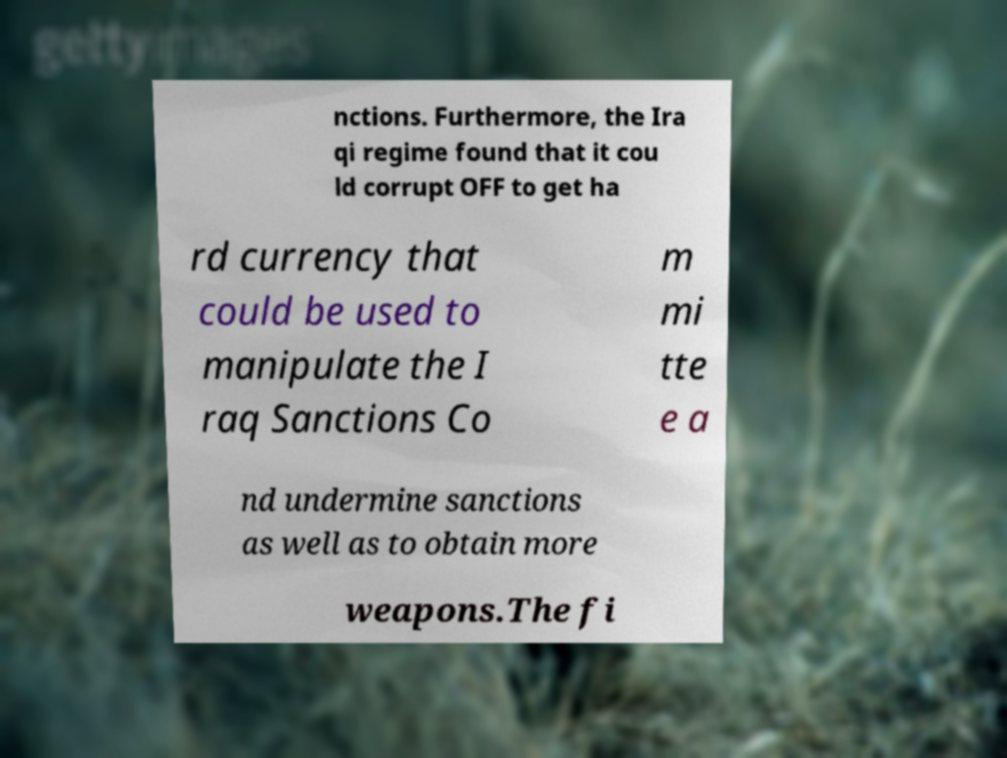What messages or text are displayed in this image? I need them in a readable, typed format. nctions. Furthermore, the Ira qi regime found that it cou ld corrupt OFF to get ha rd currency that could be used to manipulate the I raq Sanctions Co m mi tte e a nd undermine sanctions as well as to obtain more weapons.The fi 